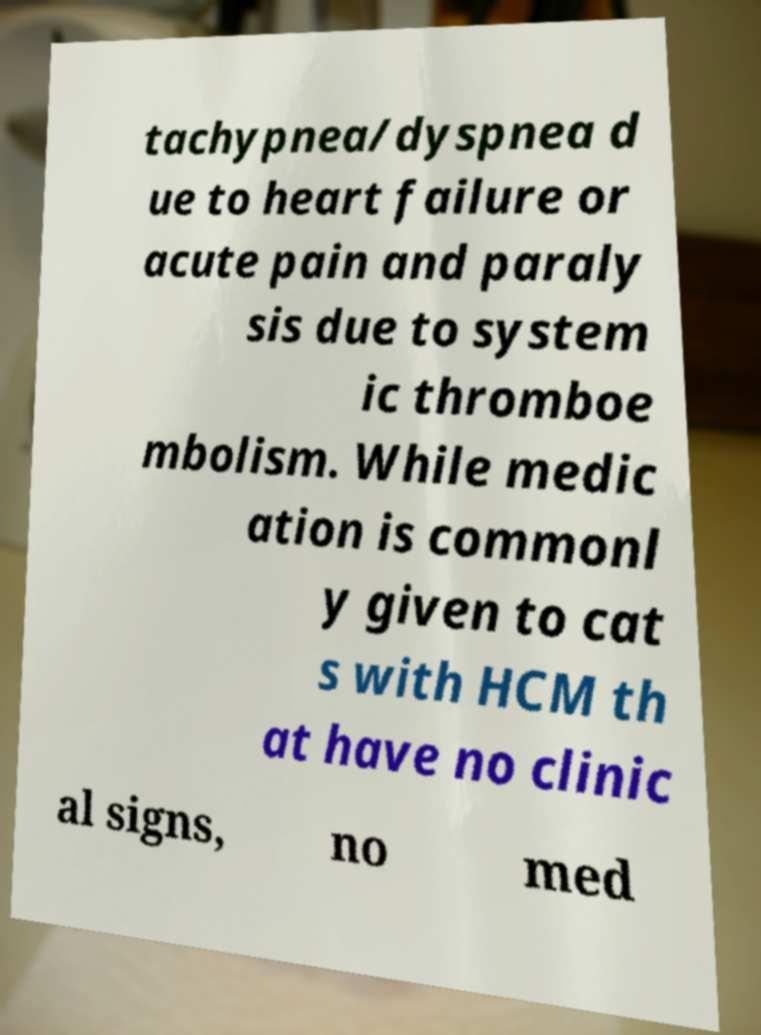Can you read and provide the text displayed in the image?This photo seems to have some interesting text. Can you extract and type it out for me? tachypnea/dyspnea d ue to heart failure or acute pain and paraly sis due to system ic thromboe mbolism. While medic ation is commonl y given to cat s with HCM th at have no clinic al signs, no med 